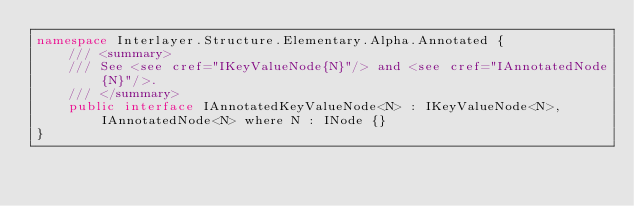Convert code to text. <code><loc_0><loc_0><loc_500><loc_500><_C#_>namespace Interlayer.Structure.Elementary.Alpha.Annotated {
    /// <summary>
    /// See <see cref="IKeyValueNode{N}"/> and <see cref="IAnnotatedNode{N}"/>.
    /// </summary>
    public interface IAnnotatedKeyValueNode<N> : IKeyValueNode<N>, IAnnotatedNode<N> where N : INode {}
}
</code> 